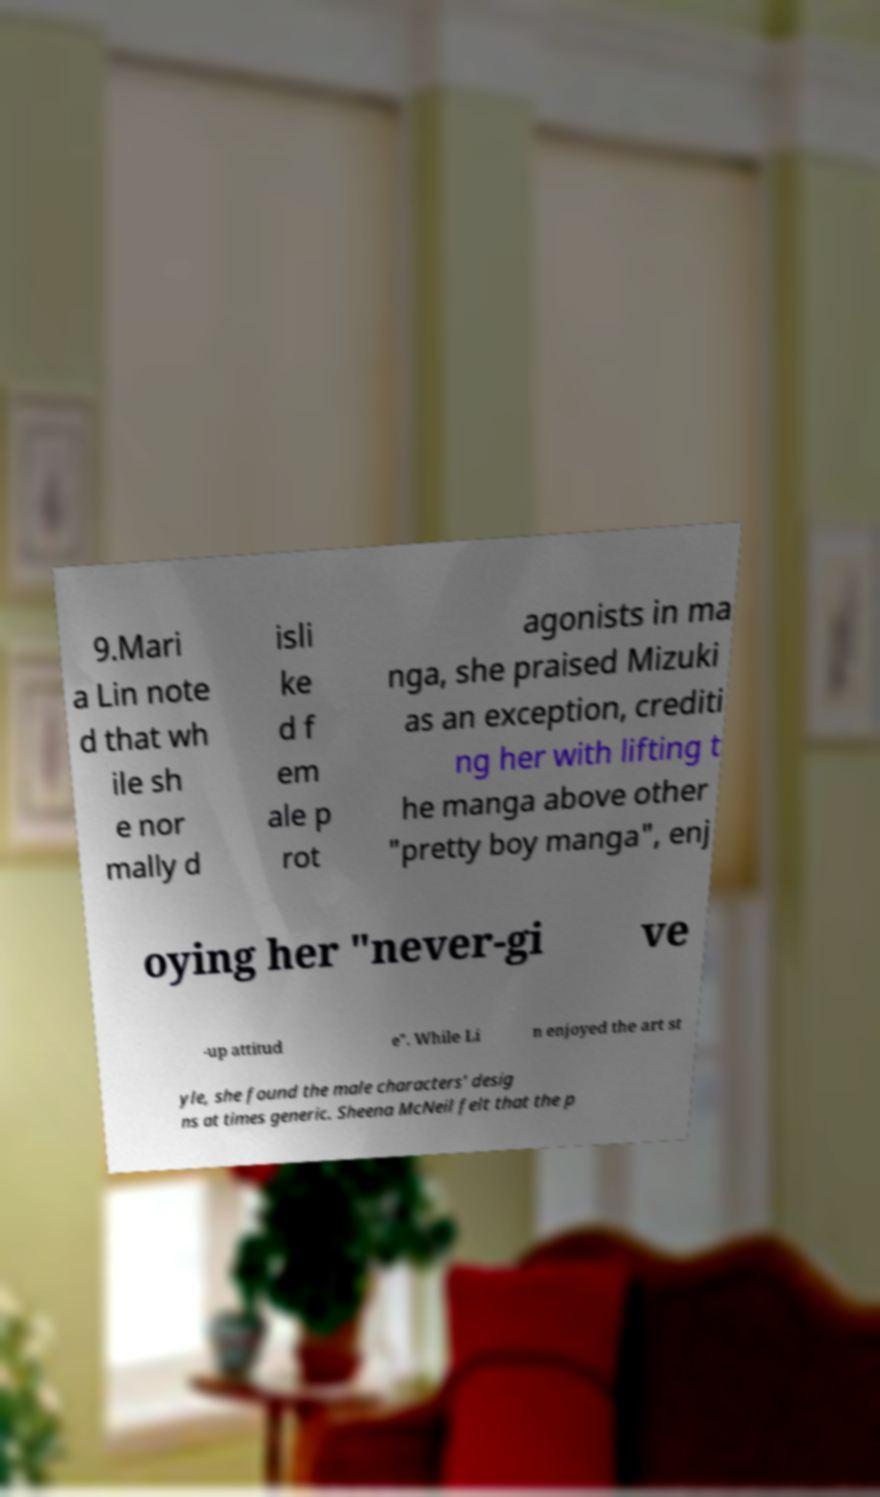Could you extract and type out the text from this image? 9.Mari a Lin note d that wh ile sh e nor mally d isli ke d f em ale p rot agonists in ma nga, she praised Mizuki as an exception, crediti ng her with lifting t he manga above other "pretty boy manga", enj oying her "never-gi ve -up attitud e". While Li n enjoyed the art st yle, she found the male characters' desig ns at times generic. Sheena McNeil felt that the p 